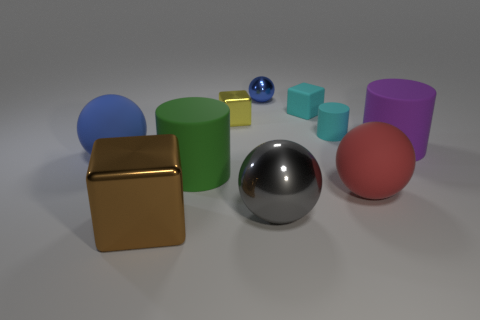Subtract 1 balls. How many balls are left? 3 Subtract all spheres. How many objects are left? 6 Add 7 big red matte balls. How many big red matte balls exist? 8 Subtract 1 blue spheres. How many objects are left? 9 Subtract all blue shiny spheres. Subtract all big purple objects. How many objects are left? 8 Add 5 red balls. How many red balls are left? 6 